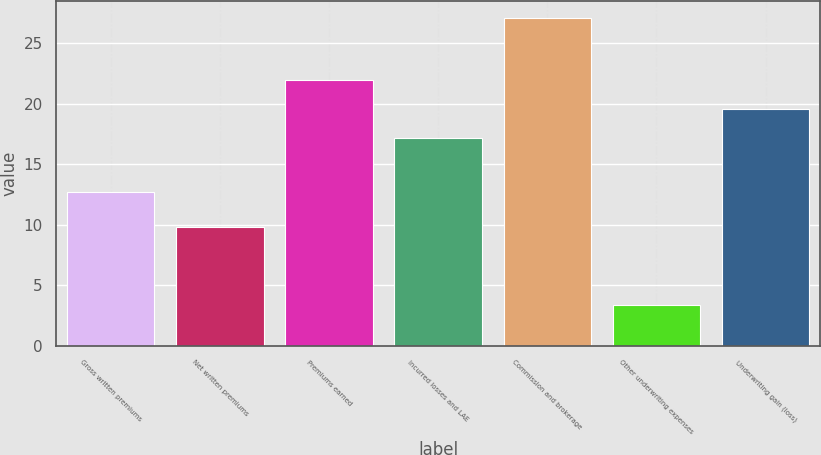Convert chart. <chart><loc_0><loc_0><loc_500><loc_500><bar_chart><fcel>Gross written premiums<fcel>Net written premiums<fcel>Premiums earned<fcel>Incurred losses and LAE<fcel>Commission and brokerage<fcel>Other underwriting expenses<fcel>Underwriting gain (loss)<nl><fcel>12.7<fcel>9.8<fcel>21.94<fcel>17.2<fcel>27.1<fcel>3.4<fcel>19.57<nl></chart> 